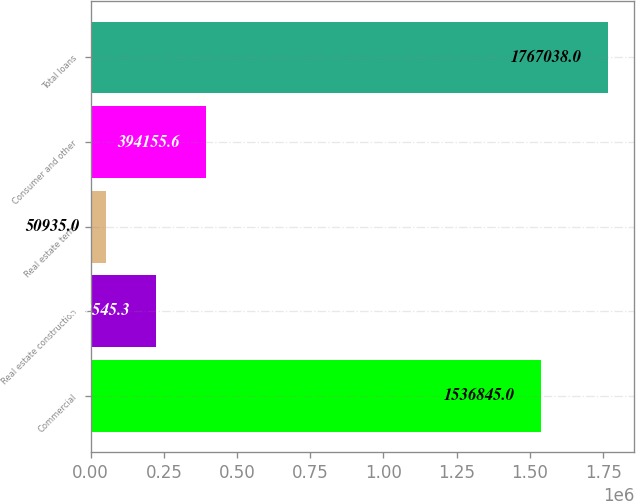Convert chart to OTSL. <chart><loc_0><loc_0><loc_500><loc_500><bar_chart><fcel>Commercial<fcel>Real estate construction<fcel>Real estate term<fcel>Consumer and other<fcel>Total loans<nl><fcel>1.53684e+06<fcel>222545<fcel>50935<fcel>394156<fcel>1.76704e+06<nl></chart> 